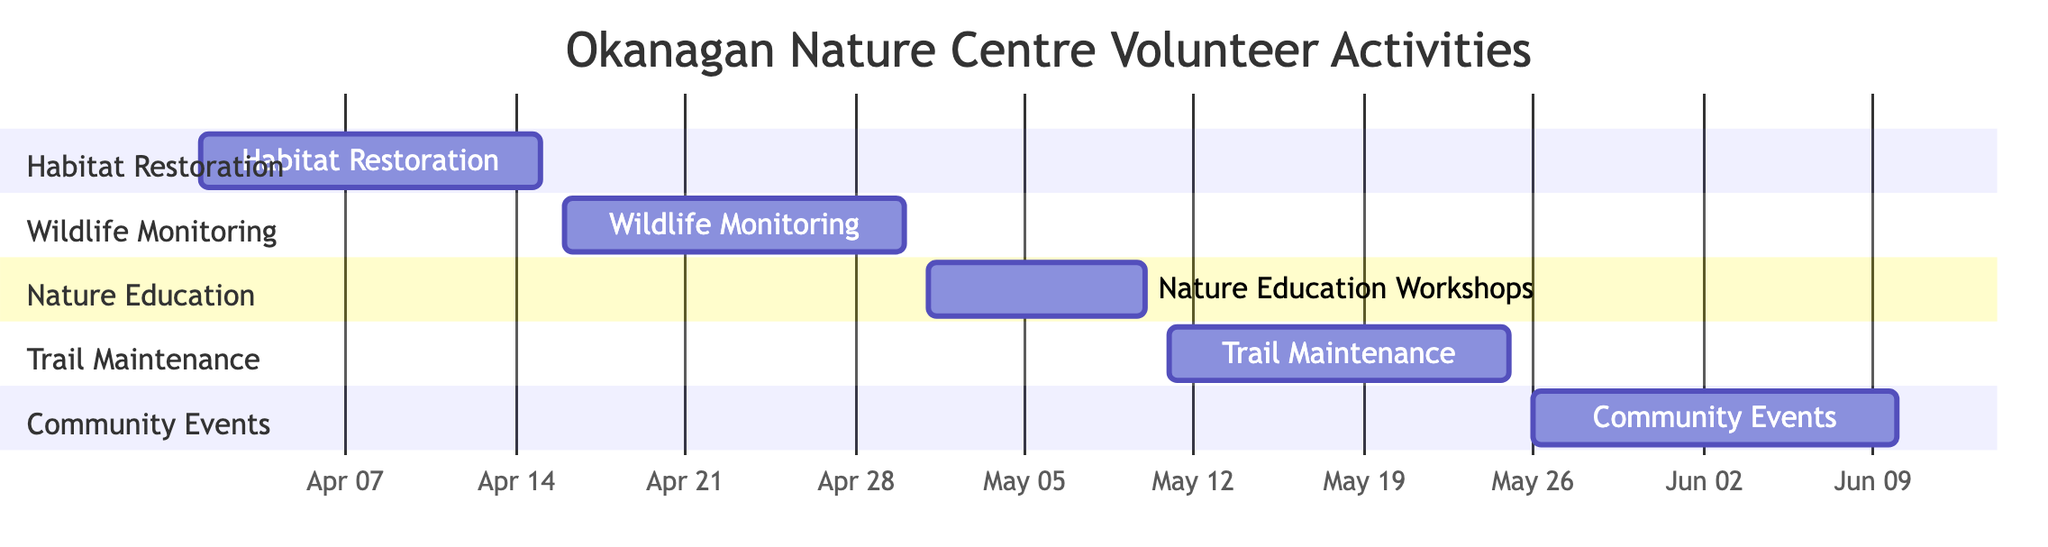What is the duration of the Habitat Restoration activity? The start date of Habitat Restoration is April 1, 2024, and the end date is April 15, 2024. Counting the days from the start to the end date gives a total of 15 days.
Answer: 15 days Which activity follows Wildlife Monitoring in the timeline? Wildlife Monitoring ends on April 30, 2024, and the very next activity starting on May 1, 2024, is Nature Education Workshops.
Answer: Nature Education Workshops How many total activities are listed in the diagram? There are five distinct activities shown in the diagram: Habitat Restoration, Wildlife Monitoring, Nature Education Workshops, Trail Maintenance, and Community Events. Counting these gives a total of 5.
Answer: 5 Which activities occur in the month of May? Looking at the start and end dates of the activities in the diagram, Nature Education Workshops (May 1-10), Trail Maintenance (May 11-25), and Community Events (May 26-June 10) all have dates in May. Combining them results in three activities in May.
Answer: 3 activities What is the end date of the last scheduled activity? The last activity is Community Events, which ends on June 10, 2024. Thus, the end date of the last scheduled activity is determined as the latest date among all activities.
Answer: June 10, 2024 Which activity lasts the longest? To determine which activity lasts the longest, we examine the duration of each: Habitat Restoration (15 days), Wildlife Monitoring (15 days), Nature Education Workshops (10 days), Trail Maintenance (15 days), and Community Events (16 days). Community Events has the longest duration of 16 days.
Answer: Community Events What is the common goal of the activities listed? From examining the descriptions of the activities, they all focus on conservation, education, and community engagement with local wildlife and habitats. Hence, the common goal highlights a focus on promoting environmental awareness and preservation.
Answer: Conservation and education 